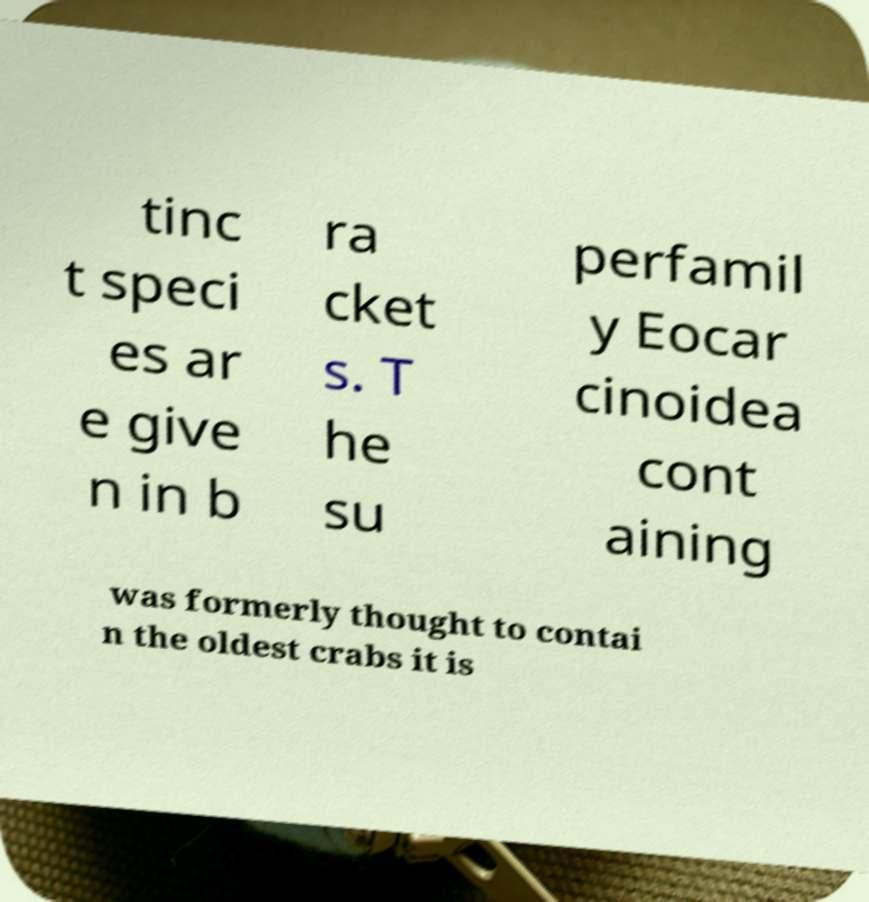What messages or text are displayed in this image? I need them in a readable, typed format. tinc t speci es ar e give n in b ra cket s. T he su perfamil y Eocar cinoidea cont aining was formerly thought to contai n the oldest crabs it is 